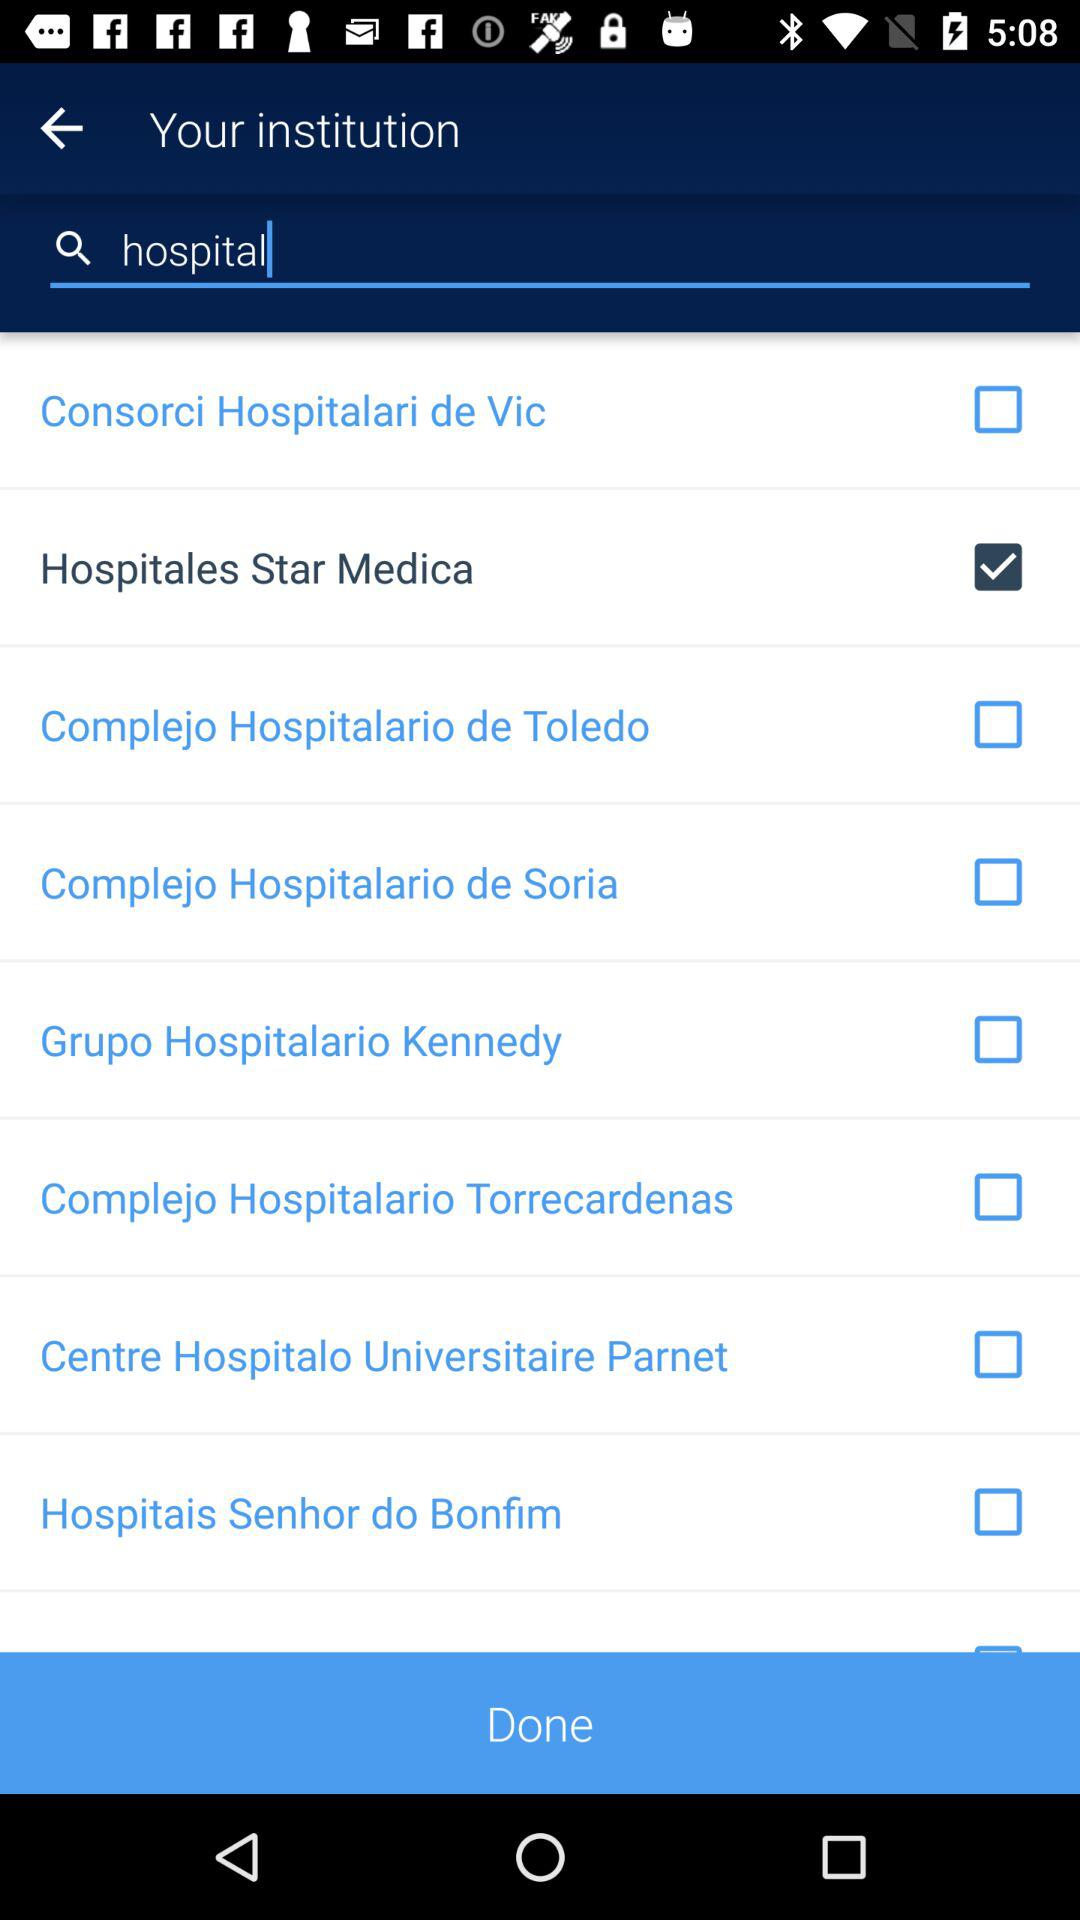Which is the selected hospital? The selected hospital is "Hospitales Star Medica". 